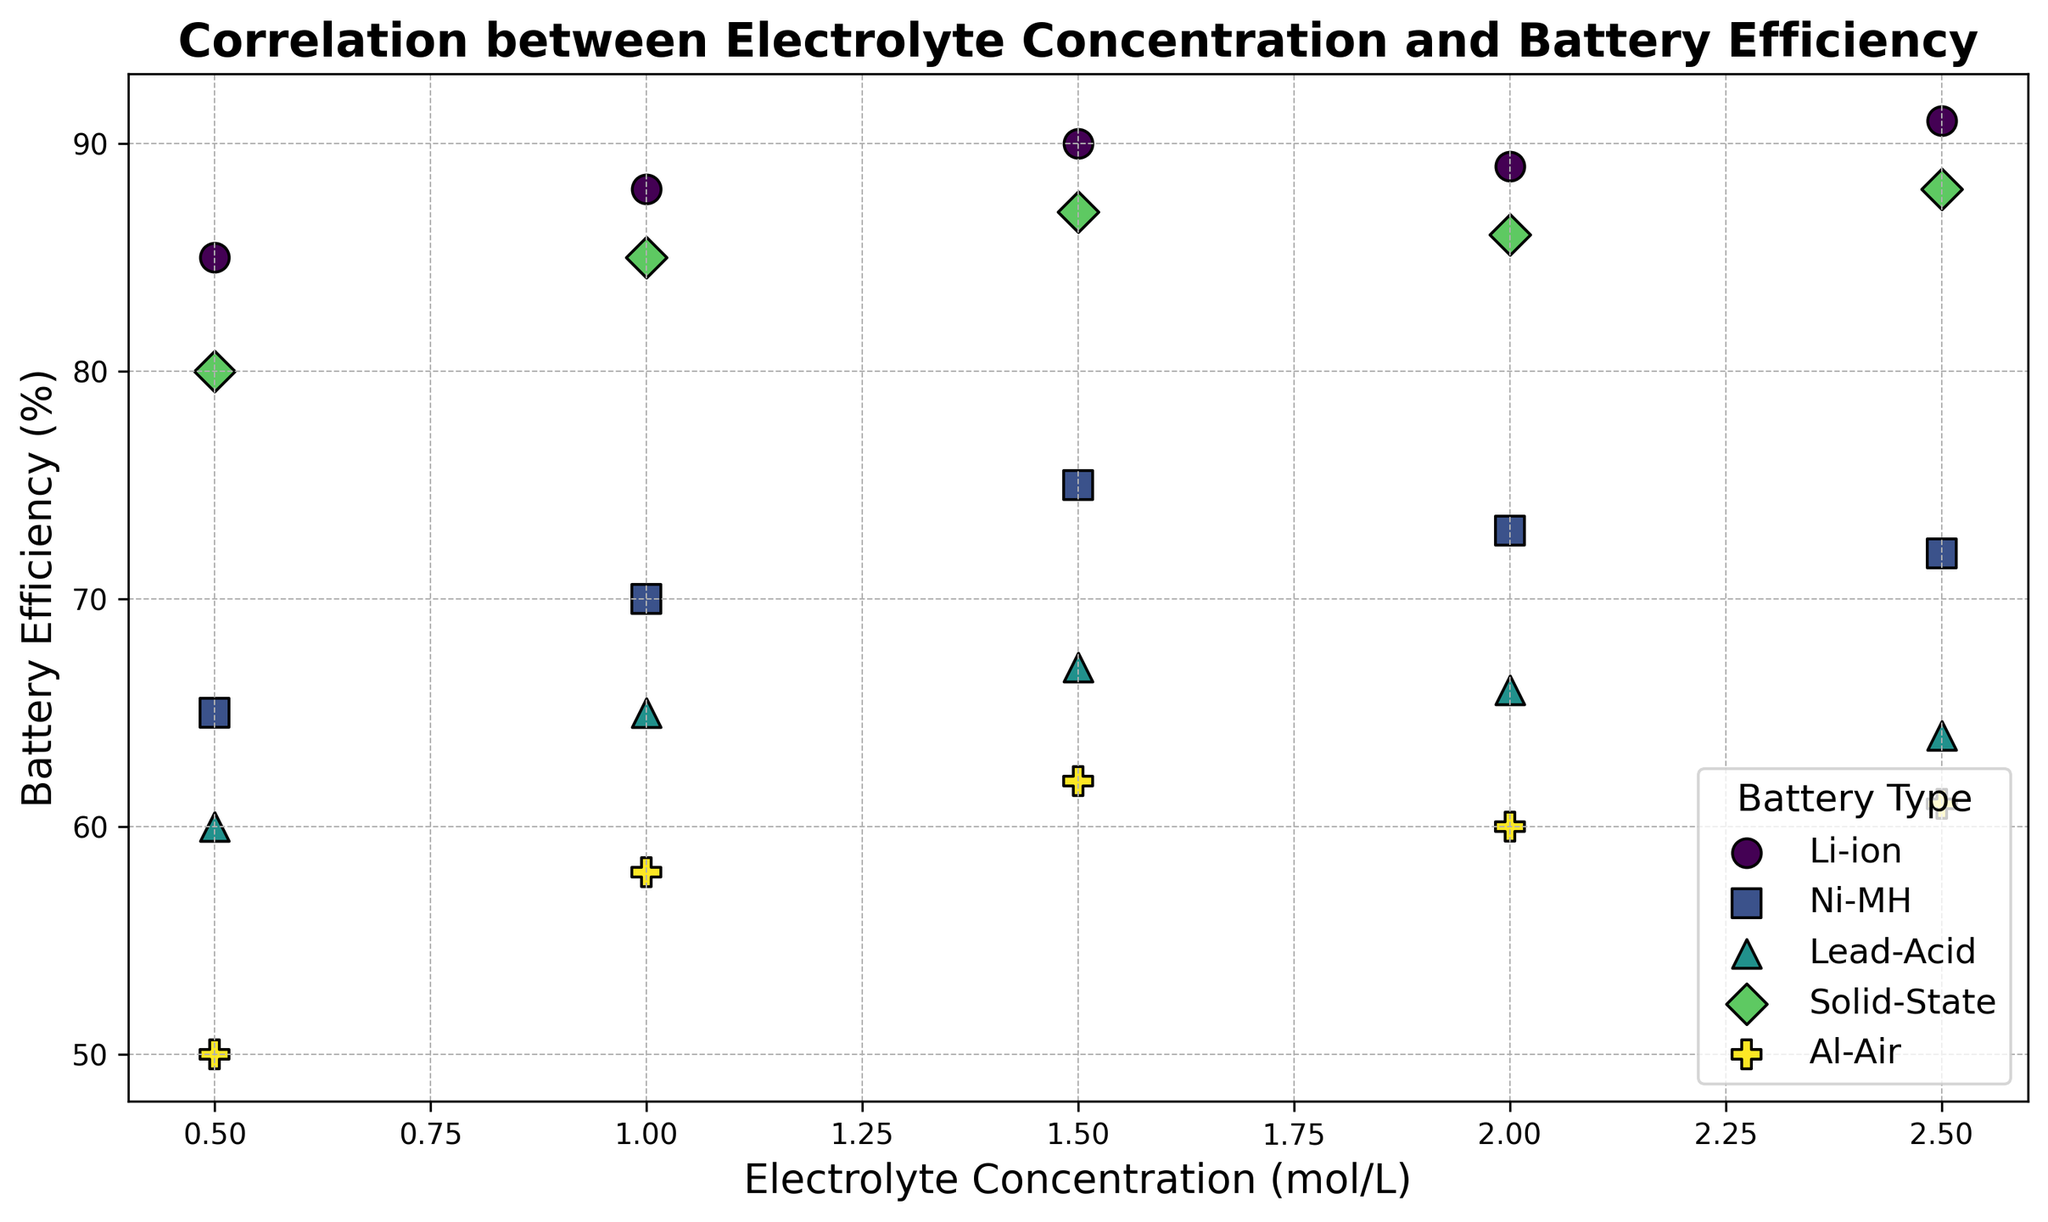What is the efficiency of the Li-ion battery at an electrolyte concentration of 1.5 mol/L? Find the data point for the Li-ion battery at an electrolyte concentration of 1.5 mol/L. The efficiency at this concentration is marked as 90% on the scatter plot.
Answer: 90% Which battery type shows the highest efficiency at an electrolyte concentration of 2.5 mol/L? Observe the scatter points for different battery types at an electrolyte concentration of 2.5 mol/L. The Li-ion battery shows the highest efficiency at 91%.
Answer: Li-ion Is the efficiency of the Ni-MH battery higher or lower than the Lead-Acid battery at an electrolyte concentration of 1.5 mol/L? Refer to the scatter points for Ni-MH and Lead-Acid batteries at 1.5 mol/L. Ni-MH has an efficiency of 75%, while Lead-Acid has an efficiency of 67%, indicating Ni-MH is higher.
Answer: Higher Which battery type has the most consistent efficiency changes across different electrolyte concentrations? Look at how the efficiency changes across various concentrations for each battery type. Li-ion and Solid-State batteries show relatively consistent efficiencies compared to others.
Answer: Li-ion or Solid-State What is the average efficiency of the Al-Air battery across all electrolyte concentrations? Sum the efficiency values for the Al-Air battery at all concentrations (50, 58, 62, 60, 61) and divide by the number of concentrations (5). Average efficiency = (50+58+62+60+61)/5 = 58.2%.
Answer: 58.2% How does the efficiency of Solid-State batteries at 1.0 mol/L compare with the efficiency of Li-ion batteries at the same concentration? Compare the scatter points for Solid-State (85%) and Li-ion (88%) batteries at 1.0 mol/L. Li-ion has a higher efficiency at this concentration.
Answer: Li-ion is higher At what electrolyte concentration do Li-ion batteries and Lead-Acid batteries both have nearly similar efficiency? Look for concentrations where the efficiencies of Li-ion and Lead-Acid batteries are close. At 2.0 mol/L, Li-ion (89%) and Lead-Acid (66%) have the closest matched efficiencies across available data.
Answer: 2.0 mol/L Which battery type shows the least variation in efficiency across electrolyte concentrations? Evaluate the range of efficiency values for each battery type. Solid-State batteries vary between 80% and 88%, showing the least variation compared to other battery types.
Answer: Solid-State What is the range of efficiencies observed for Ni-MH batteries across all electrolyte concentrations? Determine the highest and lowest efficiency values for Ni-MH batteries. The highest is 75% and the lowest is 65%, so the range is from 65% to 75%.
Answer: 65% to 75% For which battery type does an increase in electrolyte concentration not always lead to higher efficiency? Inspect the trends for each battery type. Both Ni-MH and Solid-State batteries show decreases in efficiency at certain higher concentrations, while others like Li-ion have reasonably consistent increases.
Answer: Ni-MH or Solid-State 